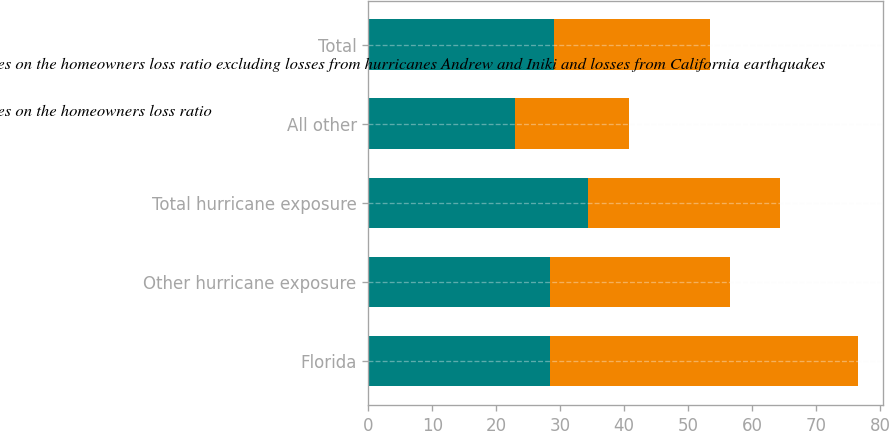<chart> <loc_0><loc_0><loc_500><loc_500><stacked_bar_chart><ecel><fcel>Florida<fcel>Other hurricane exposure<fcel>Total hurricane exposure<fcel>All other<fcel>Total<nl><fcel>Average annual impact of catastrophes on the homeowners loss ratio excluding losses from hurricanes Andrew and Iniki and losses from California earthquakes<fcel>28.4<fcel>28.4<fcel>34.4<fcel>22.9<fcel>29.1<nl><fcel>Average annual impact of catastrophes on the homeowners loss ratio<fcel>48.2<fcel>28.2<fcel>29.9<fcel>17.8<fcel>24.3<nl></chart> 